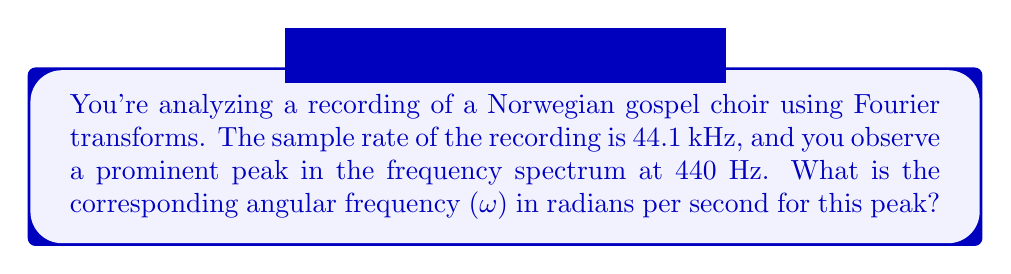Could you help me with this problem? To solve this problem, we'll follow these steps:

1. Recall the relationship between frequency (f) and angular frequency (ω):
   $$\omega = 2\pi f$$

2. We're given the frequency f = 440 Hz. Let's substitute this into the equation:
   $$\omega = 2\pi (440)$$

3. Now, let's calculate:
   $$\omega = 2 * 3.14159... * 440$$
   $$\omega ≈ 2763.89$$

4. Round to two decimal places:
   $$\omega ≈ 2763.89 \text{ rad/s}$$

The angular frequency is approximately 2763.89 radians per second.
Answer: $2763.89 \text{ rad/s}$ 